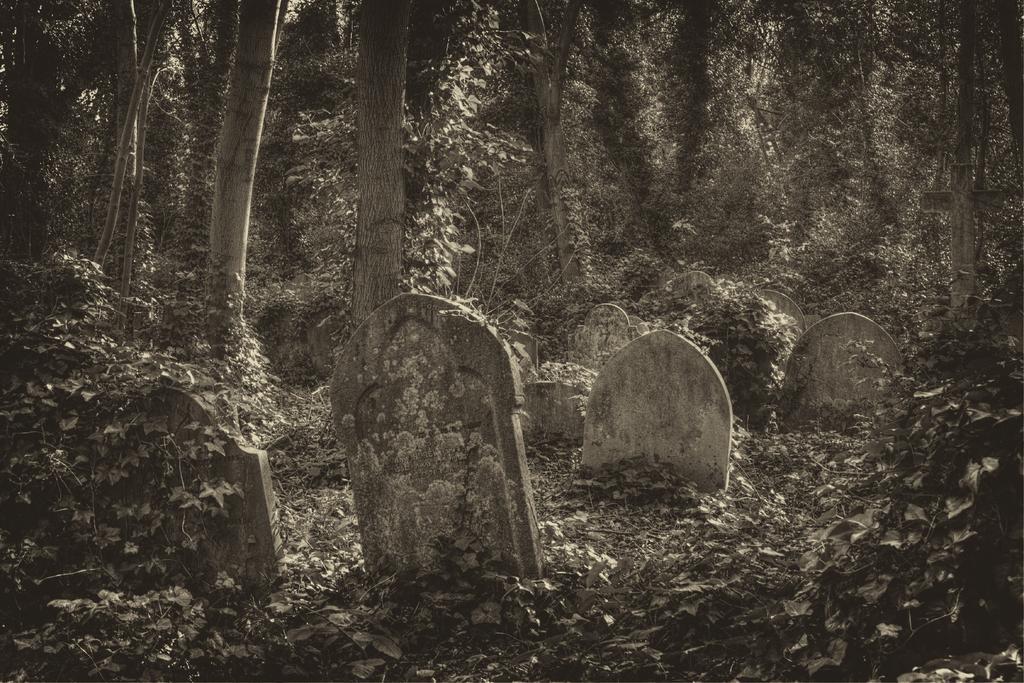In one or two sentences, can you explain what this image depicts? In this picture we can observe grave stones. There are some dry leaves. In the background we can observe trees. This is a black and white image. 